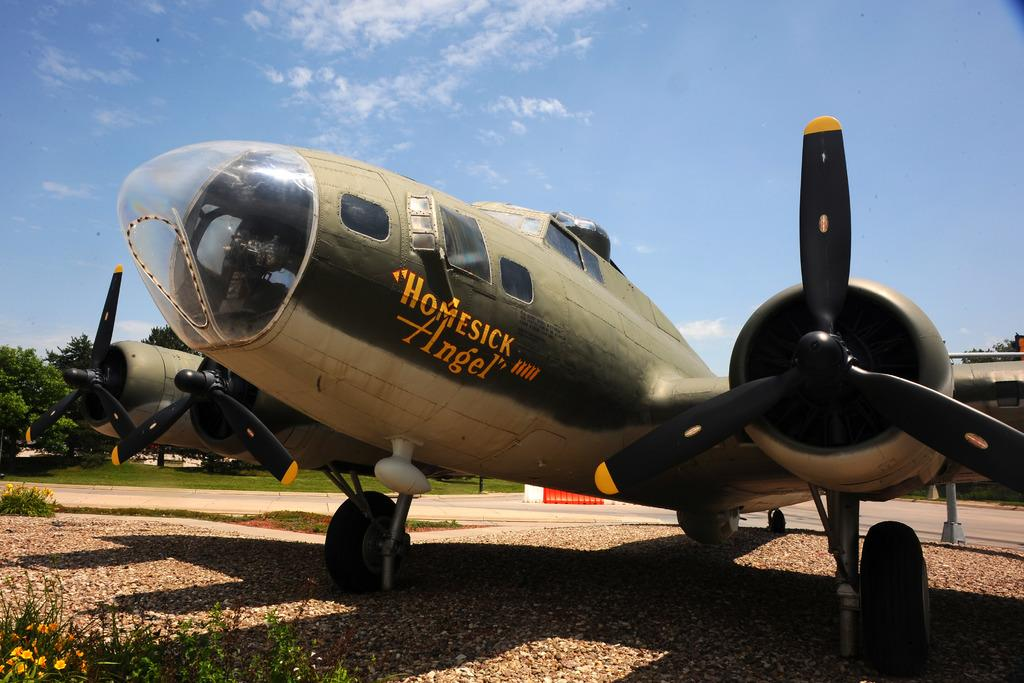<image>
Provide a brief description of the given image. A restored old war plane is displayed with the name on the side that reads "Homesick Angel" 